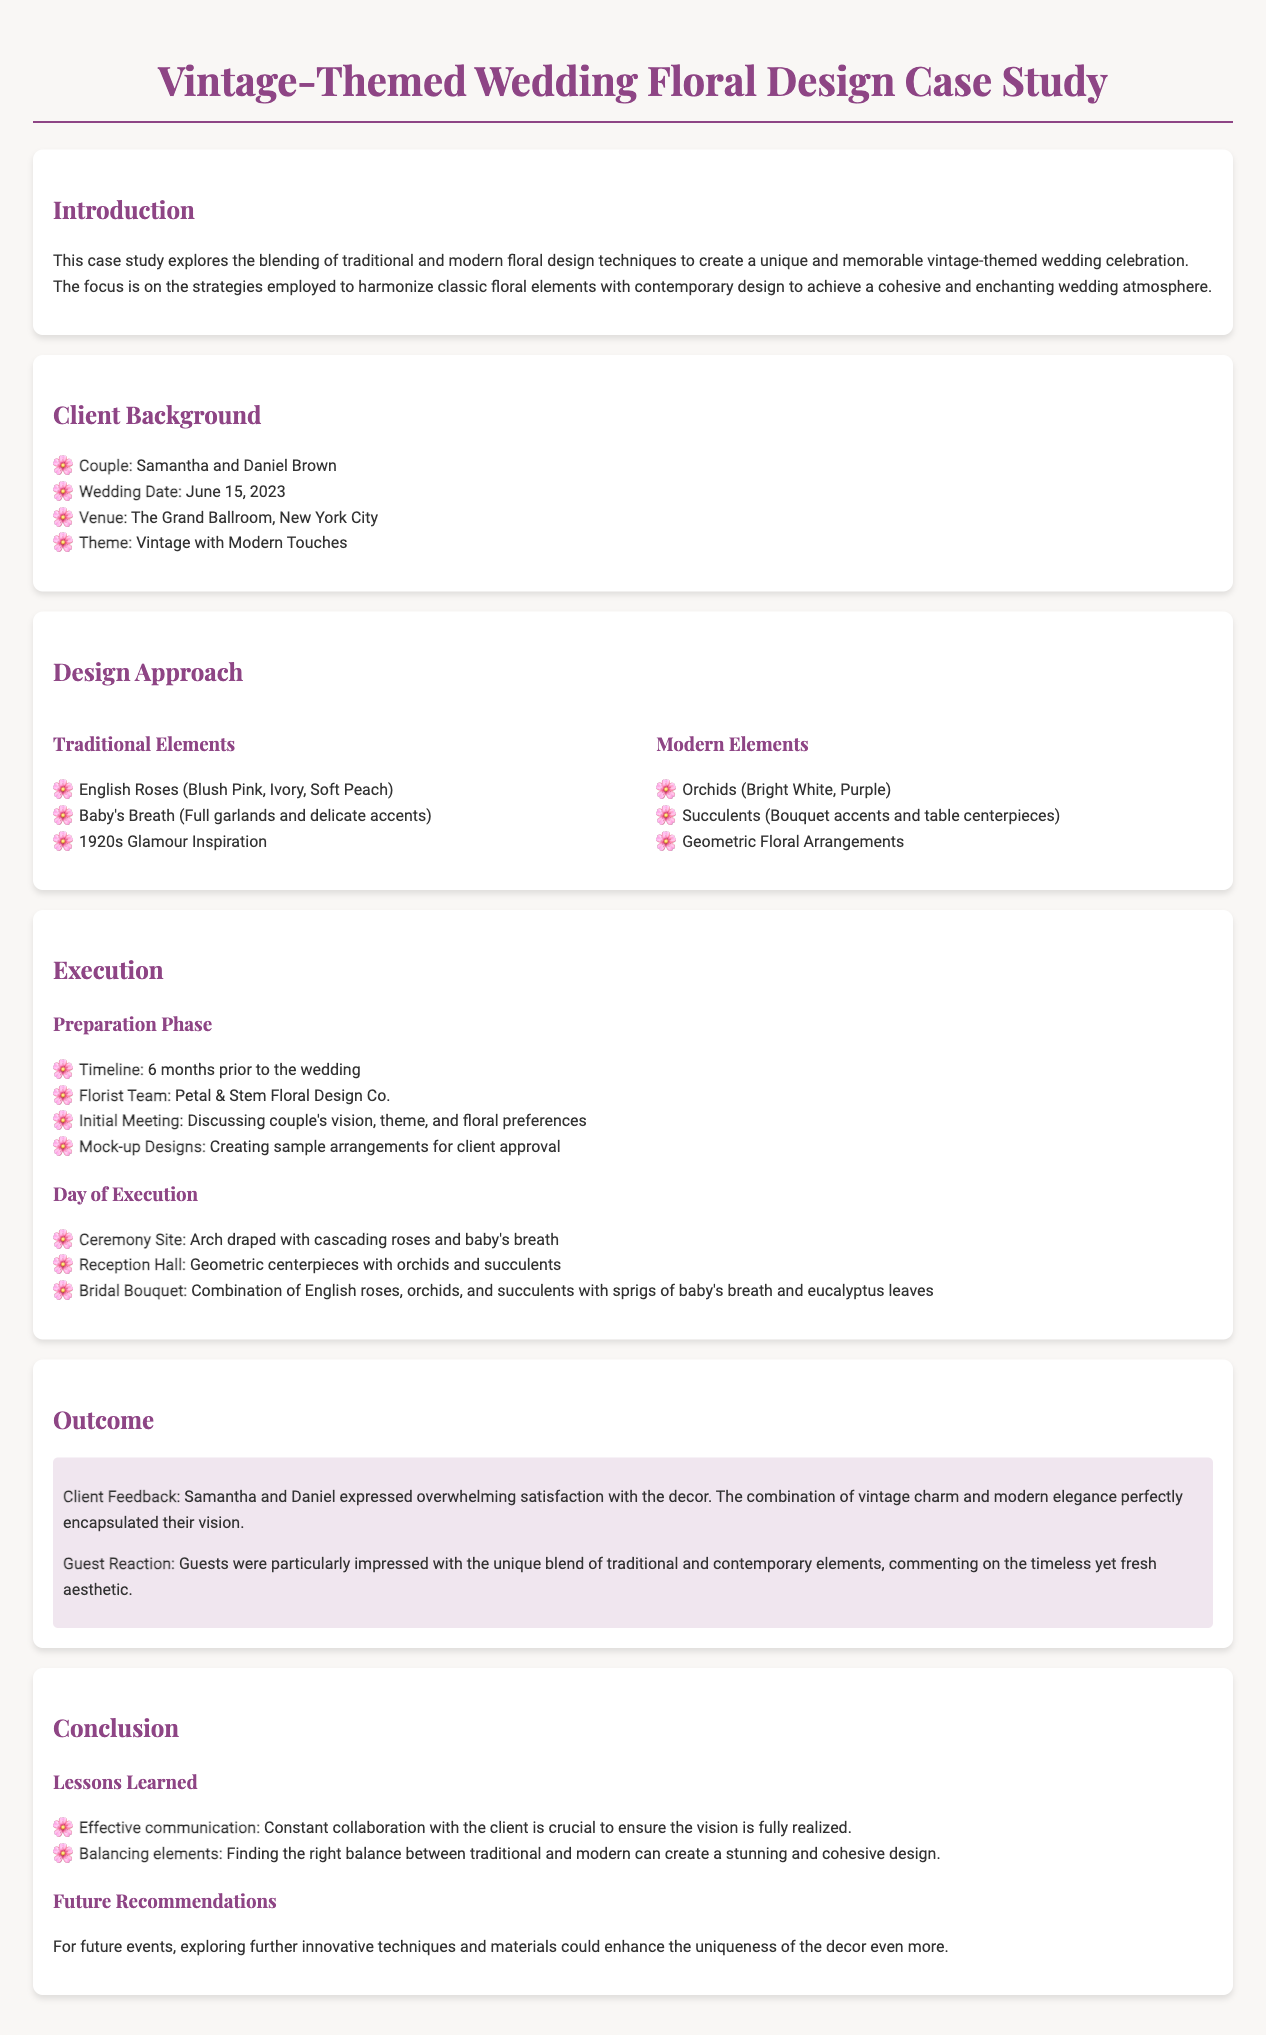What is the couple's name? The couple's name can be found in the Client Background section as Samantha and Daniel Brown.
Answer: Samantha and Daniel Brown When is the wedding date? The wedding date is mentioned in the Client Background section.
Answer: June 15, 2023 Where is the venue located? The venue location is specified in the Client Background section as The Grand Ballroom, New York City.
Answer: The Grand Ballroom, New York City What traditional floral element is listed first? The first traditional floral element can be found in the Design Approach section under Traditional Elements.
Answer: English Roses (Blush Pink, Ivory, Soft Peach) What modern floral element features geometric arrangements? The document mentions geometric floral arrangements as a modern element in the Design Approach section.
Answer: Geometric Floral Arrangements What was the florists' team name? The name of the florist team can be found in the Execution section under Preparation Phase.
Answer: Petal & Stem Floral Design Co What was a highlight of client feedback? In the Outcome section, the client feedback highlights their satisfaction with the decor and how it matched their vision.
Answer: Overwhelming satisfaction with the decor What is one lesson learned from this case study? The lessons learned are outlined in the Conclusion section, one of which is about effective communication.
Answer: Effective communication 